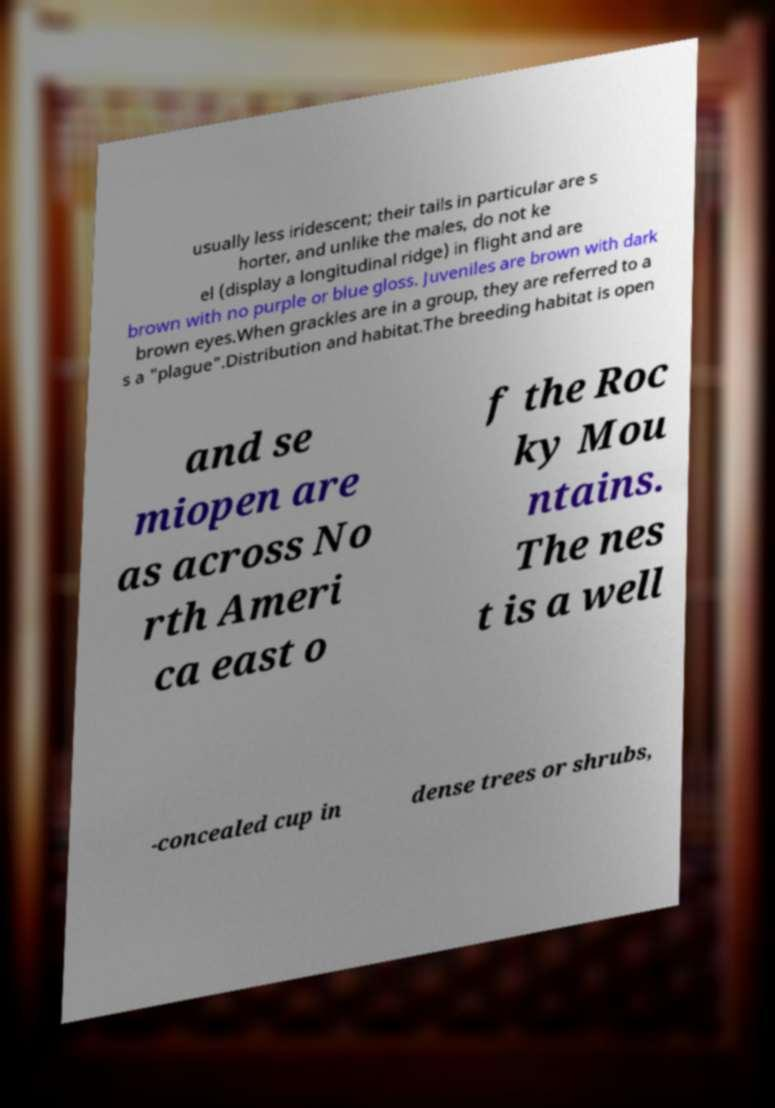Could you extract and type out the text from this image? usually less iridescent; their tails in particular are s horter, and unlike the males, do not ke el (display a longitudinal ridge) in flight and are brown with no purple or blue gloss. Juveniles are brown with dark brown eyes.When grackles are in a group, they are referred to a s a "plague".Distribution and habitat.The breeding habitat is open and se miopen are as across No rth Ameri ca east o f the Roc ky Mou ntains. The nes t is a well -concealed cup in dense trees or shrubs, 